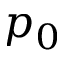<formula> <loc_0><loc_0><loc_500><loc_500>p _ { 0 }</formula> 